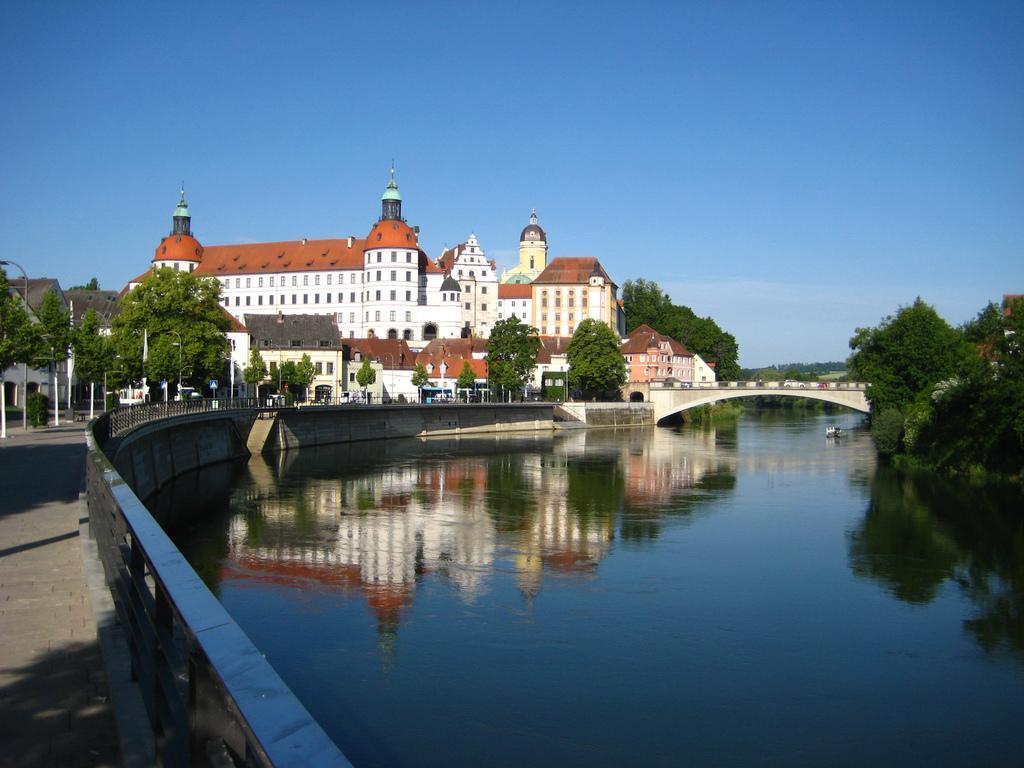How would you summarize this image in a sentence or two? In this image on the right side, I can see the water. In the background, I can see the trees, houses and clouds in the sky. 